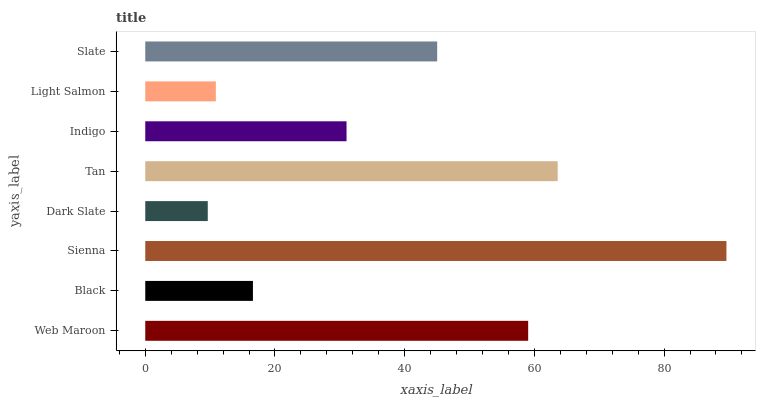Is Dark Slate the minimum?
Answer yes or no. Yes. Is Sienna the maximum?
Answer yes or no. Yes. Is Black the minimum?
Answer yes or no. No. Is Black the maximum?
Answer yes or no. No. Is Web Maroon greater than Black?
Answer yes or no. Yes. Is Black less than Web Maroon?
Answer yes or no. Yes. Is Black greater than Web Maroon?
Answer yes or no. No. Is Web Maroon less than Black?
Answer yes or no. No. Is Slate the high median?
Answer yes or no. Yes. Is Indigo the low median?
Answer yes or no. Yes. Is Indigo the high median?
Answer yes or no. No. Is Tan the low median?
Answer yes or no. No. 